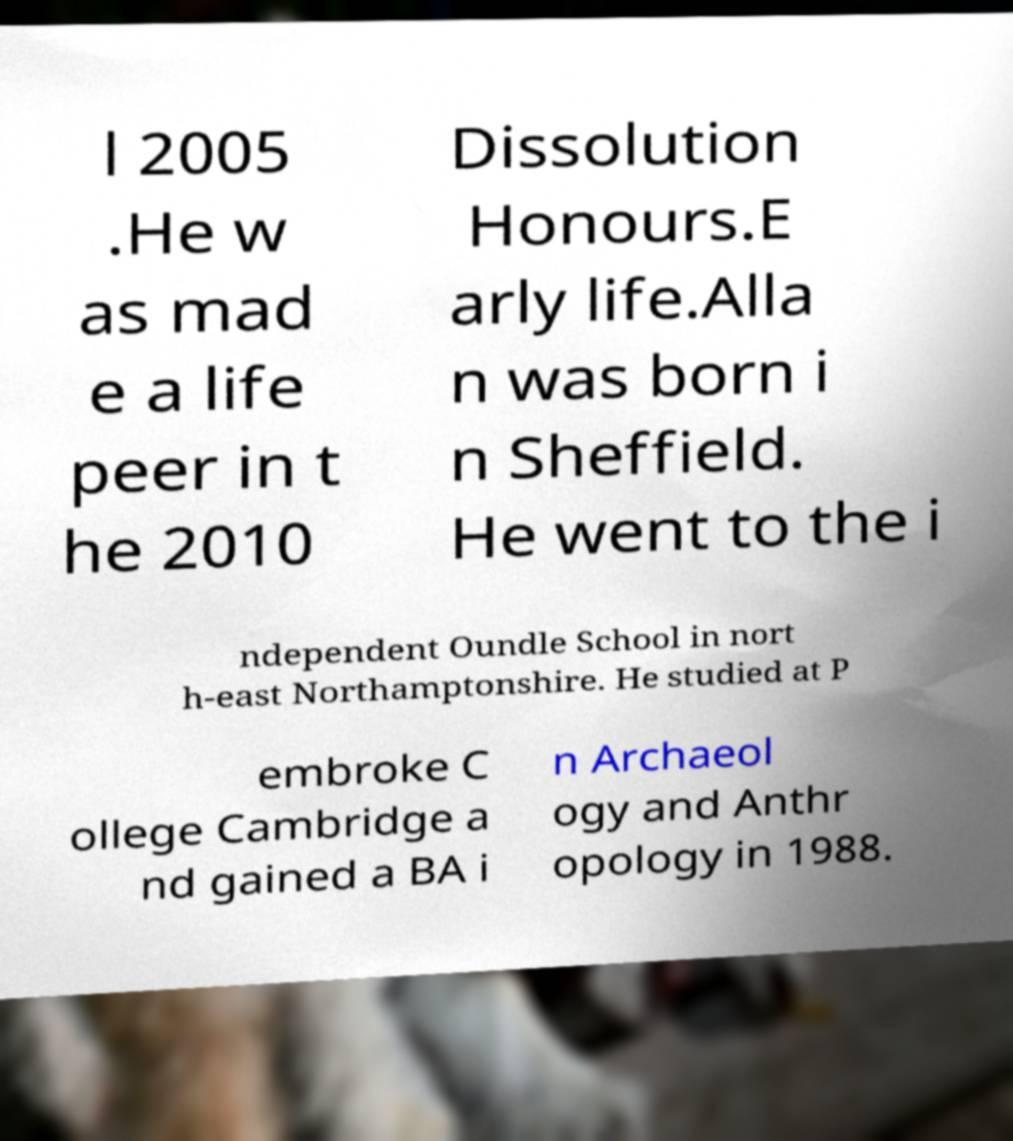Can you read and provide the text displayed in the image?This photo seems to have some interesting text. Can you extract and type it out for me? l 2005 .He w as mad e a life peer in t he 2010 Dissolution Honours.E arly life.Alla n was born i n Sheffield. He went to the i ndependent Oundle School in nort h-east Northamptonshire. He studied at P embroke C ollege Cambridge a nd gained a BA i n Archaeol ogy and Anthr opology in 1988. 